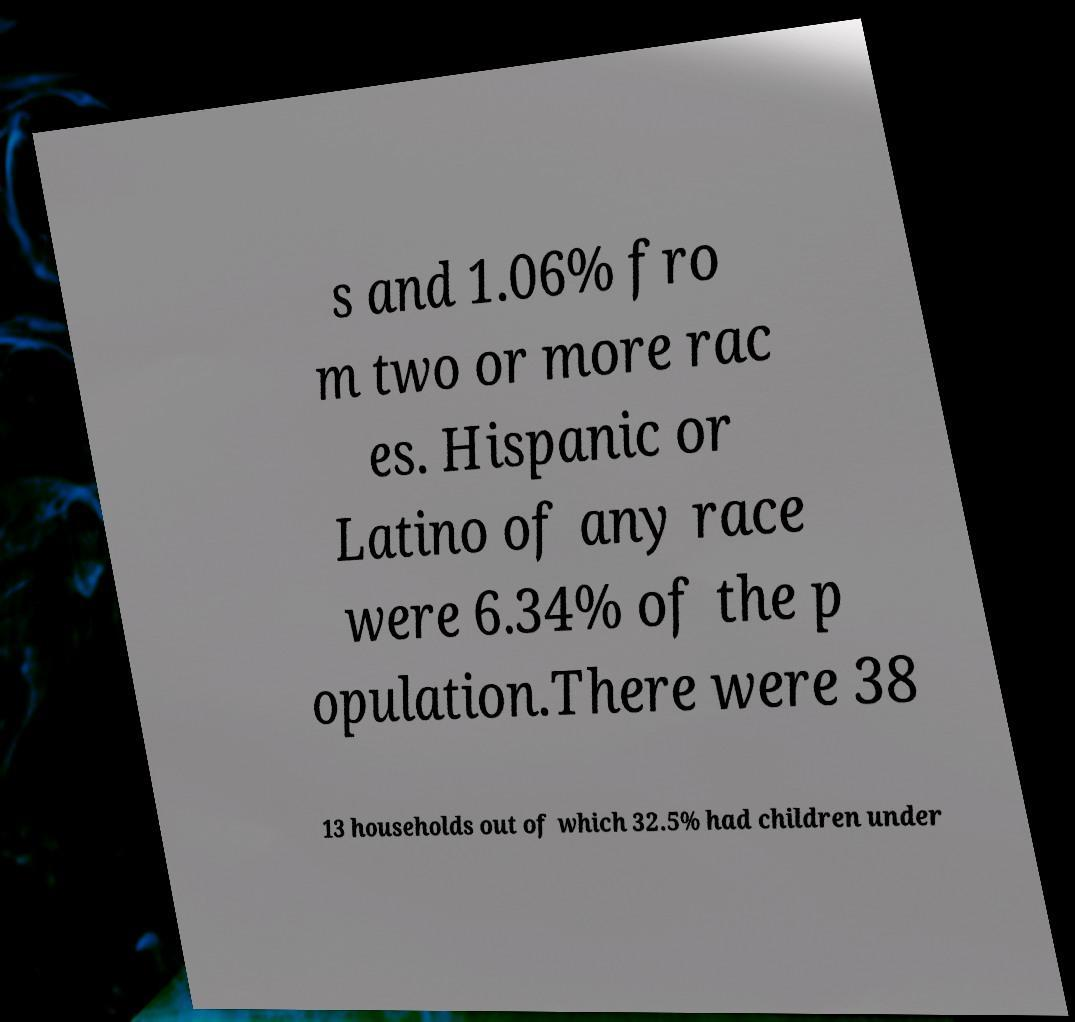Could you assist in decoding the text presented in this image and type it out clearly? s and 1.06% fro m two or more rac es. Hispanic or Latino of any race were 6.34% of the p opulation.There were 38 13 households out of which 32.5% had children under 